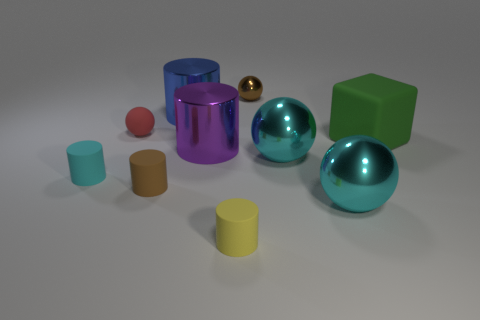There is a cylinder that is the same color as the tiny shiny object; what material is it?
Ensure brevity in your answer.  Rubber. What is the thing that is both on the right side of the small yellow object and behind the tiny red thing made of?
Your response must be concise. Metal. What is the color of the big rubber thing?
Your answer should be compact. Green. Are there any other things that are made of the same material as the blue thing?
Provide a succinct answer. Yes. What is the shape of the thing on the left side of the tiny red sphere?
Give a very brief answer. Cylinder. Is there a shiny cylinder that is on the right side of the big metallic cylinder in front of the shiny cylinder behind the big block?
Provide a short and direct response. No. Is there anything else that is the same shape as the large blue thing?
Ensure brevity in your answer.  Yes. Are any tiny blue balls visible?
Keep it short and to the point. No. Are the big thing behind the big rubber cube and the tiny brown object that is to the left of the big purple object made of the same material?
Provide a short and direct response. No. There is a metallic cylinder behind the small sphere that is left of the brown thing to the right of the yellow thing; what size is it?
Your answer should be very brief. Large. 